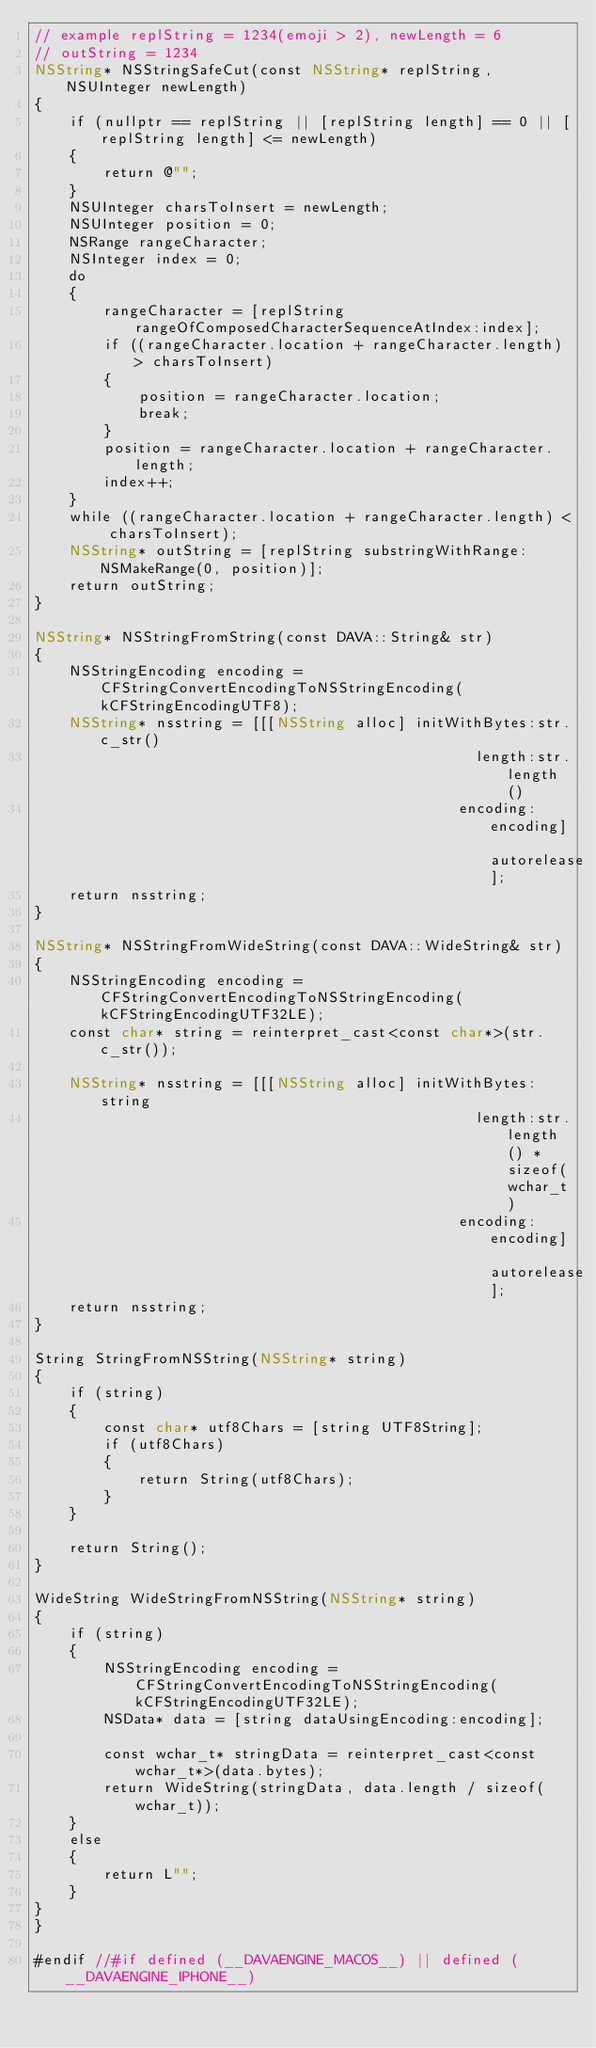Convert code to text. <code><loc_0><loc_0><loc_500><loc_500><_ObjectiveC_>// example replString = 1234(emoji > 2), newLength = 6
// outString = 1234
NSString* NSStringSafeCut(const NSString* replString, NSUInteger newLength)
{
    if (nullptr == replString || [replString length] == 0 || [replString length] <= newLength)
    {
        return @"";
    }
    NSUInteger charsToInsert = newLength;
    NSUInteger position = 0;
    NSRange rangeCharacter;
    NSInteger index = 0;
    do
    {
        rangeCharacter = [replString rangeOfComposedCharacterSequenceAtIndex:index];
        if ((rangeCharacter.location + rangeCharacter.length) > charsToInsert)
        {
            position = rangeCharacter.location;
            break;
        }
        position = rangeCharacter.location + rangeCharacter.length;
        index++;
    }
    while ((rangeCharacter.location + rangeCharacter.length) < charsToInsert);
    NSString* outString = [replString substringWithRange:NSMakeRange(0, position)];
    return outString;
}

NSString* NSStringFromString(const DAVA::String& str)
{
    NSStringEncoding encoding = CFStringConvertEncodingToNSStringEncoding(kCFStringEncodingUTF8);
    NSString* nsstring = [[[NSString alloc] initWithBytes:str.c_str()
                                                   length:str.length()
                                                 encoding:encoding] autorelease];
    return nsstring;
}

NSString* NSStringFromWideString(const DAVA::WideString& str)
{
    NSStringEncoding encoding = CFStringConvertEncodingToNSStringEncoding(kCFStringEncodingUTF32LE);
    const char* string = reinterpret_cast<const char*>(str.c_str());

    NSString* nsstring = [[[NSString alloc] initWithBytes:string
                                                   length:str.length() * sizeof(wchar_t)
                                                 encoding:encoding] autorelease];
    return nsstring;
}

String StringFromNSString(NSString* string)
{
    if (string)
    {
        const char* utf8Chars = [string UTF8String];
        if (utf8Chars)
        {
            return String(utf8Chars);
        }
    }

    return String();
}

WideString WideStringFromNSString(NSString* string)
{
    if (string)
    {
        NSStringEncoding encoding = CFStringConvertEncodingToNSStringEncoding(kCFStringEncodingUTF32LE);
        NSData* data = [string dataUsingEncoding:encoding];

        const wchar_t* stringData = reinterpret_cast<const wchar_t*>(data.bytes);
        return WideString(stringData, data.length / sizeof(wchar_t));
    }
    else
    {
        return L"";
    }
}
}

#endif //#if defined (__DAVAENGINE_MACOS__) || defined (__DAVAENGINE_IPHONE__)
</code> 